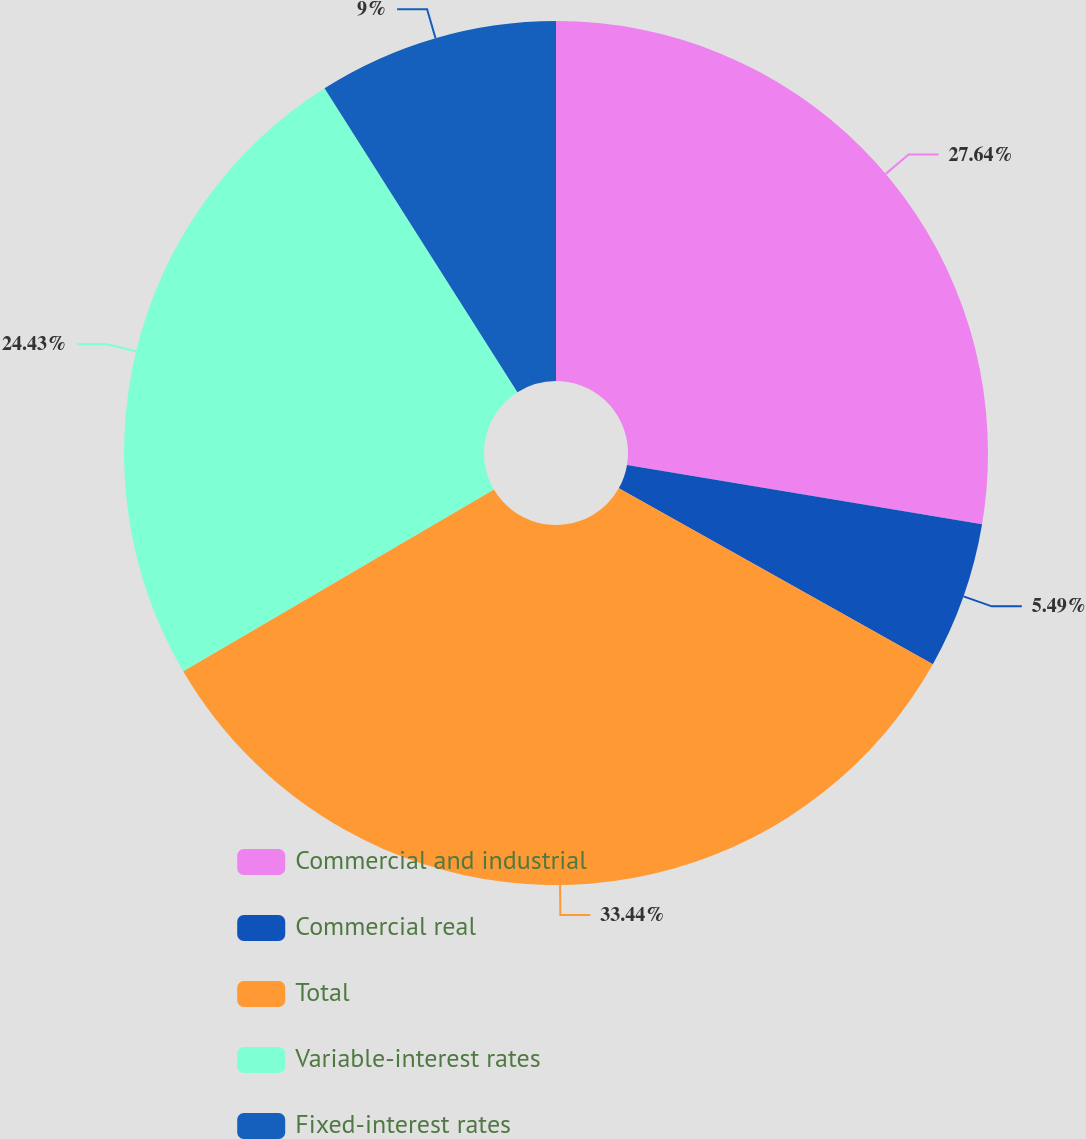Convert chart to OTSL. <chart><loc_0><loc_0><loc_500><loc_500><pie_chart><fcel>Commercial and industrial<fcel>Commercial real<fcel>Total<fcel>Variable-interest rates<fcel>Fixed-interest rates<nl><fcel>27.64%<fcel>5.49%<fcel>33.44%<fcel>24.43%<fcel>9.0%<nl></chart> 